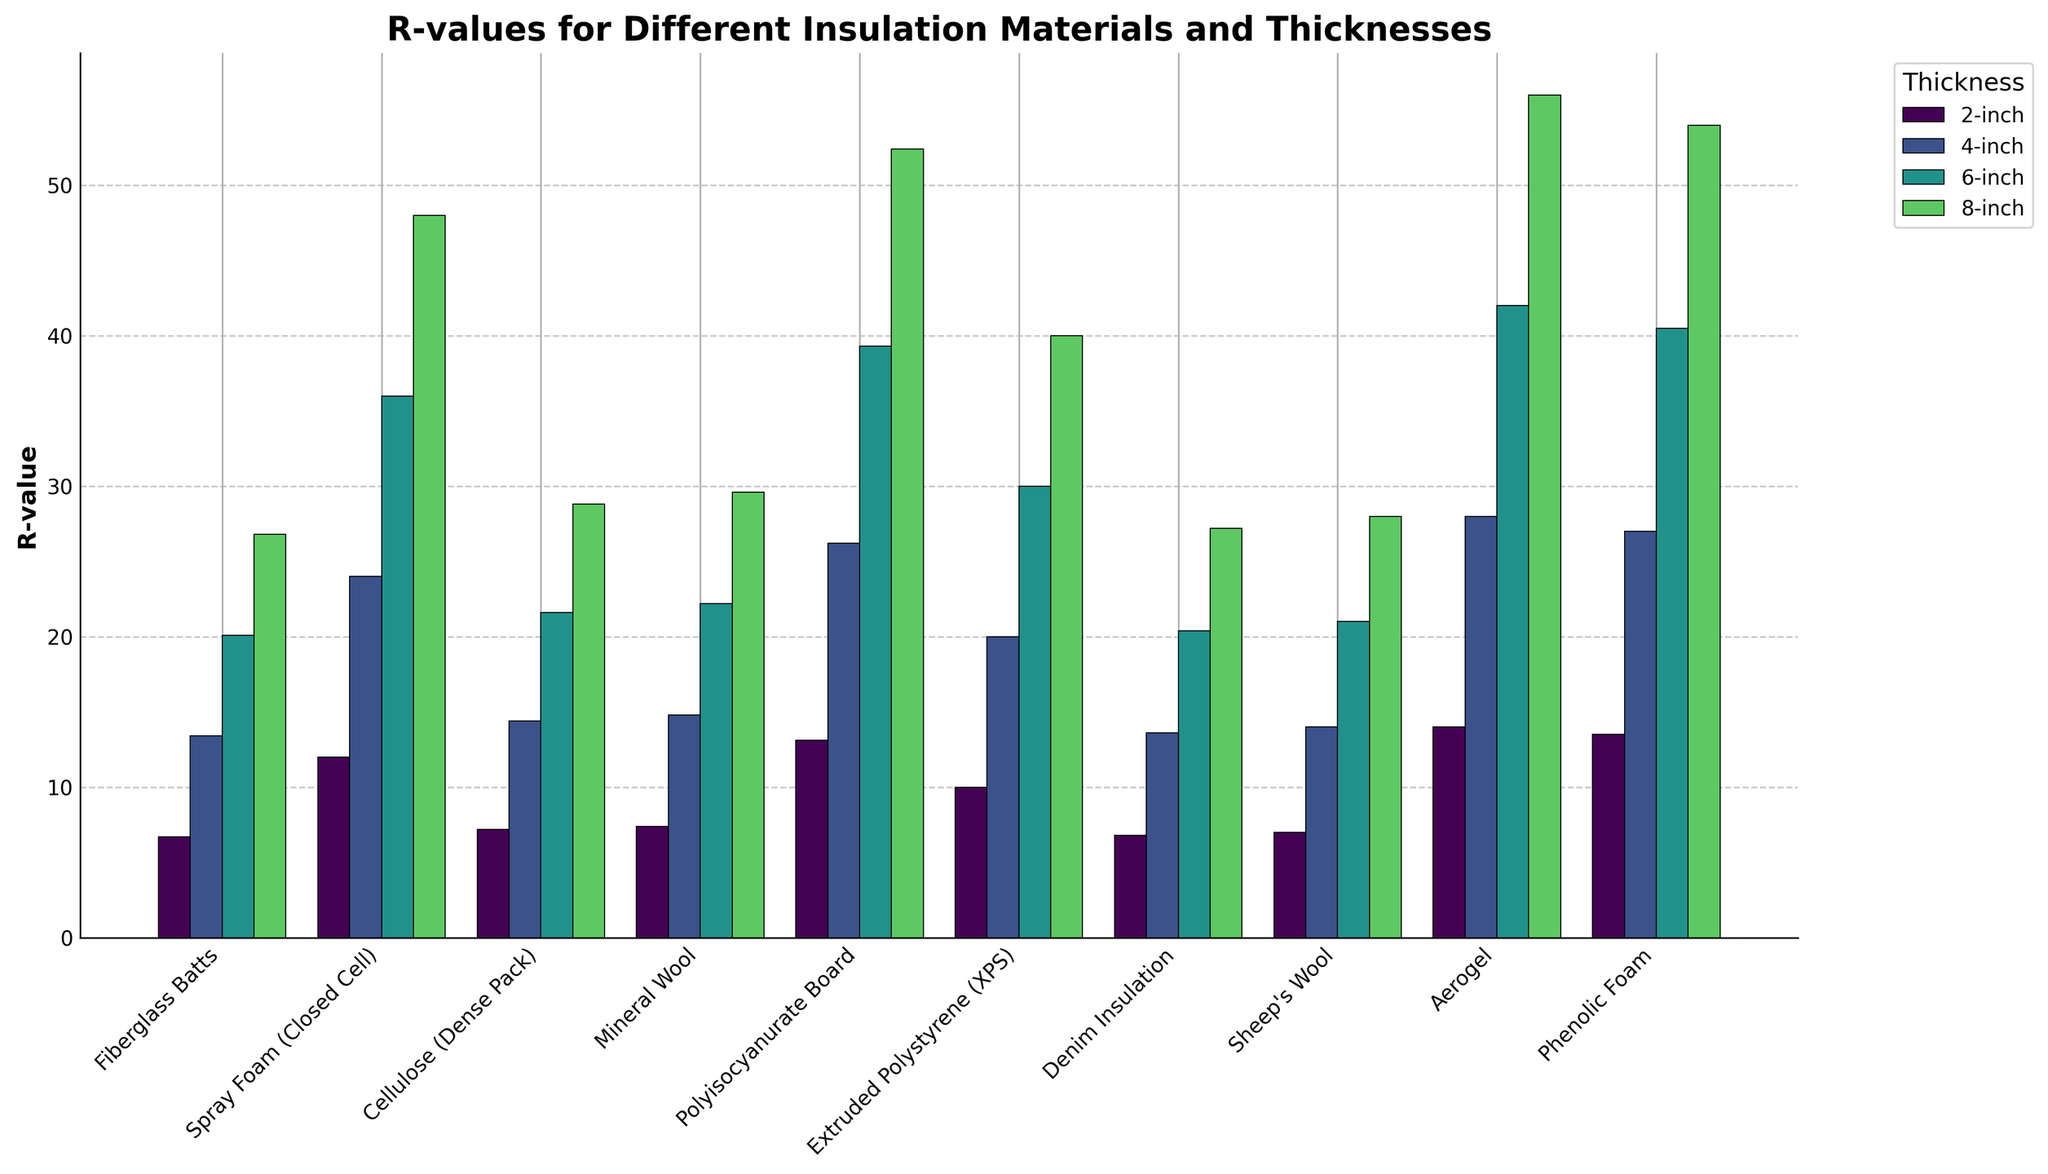Which insulation material has the highest 2-inch R-value? Locate the bars for 2-inch thickness on the figure. Identify the tallest bar that represents the highest R-value.
Answer: Aerogel How does the 4-inch R-value of Fiberglass Batts compare to that of Polyisocyanurate Board? Locate the bars for 4-inch thickness for both Fiberglass Batts and Polyisocyanurate Board. Compare their heights to determine which one is taller.
Answer: Polyisocyanurate Board is higher What's the average 6-inch R-value for Fiberglass Batts, Spray Foam (Closed Cell), and Cellulose (Dense Pack)? Identify the 6-inch R-values for Fiberglass Batts (20.1), Spray Foam (36.0), and Cellulose (21.6). Calculate the average: (20.1 + 36.0 + 21.6) / 3 = 25.9.
Answer: 25.9 Which material shows the least increase in R-value from 2-inch to 4-inch thickness? Calculate the increase for each material: subtract the 2-inch R-value from the 4-inch R-value. Identify the smallest difference.
Answer: Denim Insulation (6.8 to 13.6, increase of 6.8) What is the total R-value for 8-inch Spray Foam and 4-inch Aerogel combined? Locate the corresponding R-values for 8-inch Spray Foam (48.0) and 4-inch Aerogel (28.0). Add them together: 48.0 + 28.0 = 76.0.
Answer: 76.0 Is the R-value of 6-inch Sheep's Wool greater than the R-value of 4-inch Extruded Polystyrene (XPS)? Compare the R-values for 6-inch Sheep's Wool (21.0) and 4-inch XPS (20.0). Identify if the former is greater.
Answer: Yes Which material provides an R-value of at least 25.0 for 8-inch thickness but not more than 30.0? Identify the 8-inch R-values and find which ones fall between 25.0 and 30.0.
Answer: Fiberglass Batts, Cellulose (Dense Pack), Mineral Wool, Denim Insulation, Sheep's Wool Does Phenolic Foam at 4-inch thickness have a higher R-value than Mineral Wool at 6-inch thickness? Compare the R-values for Phenolic Foam at 4-inch (27.0) and Mineral Wool at 6-inch (22.2). Determine if the former is higher.
Answer: Yes Which material experiences the largest absolute R-value increase from 6 inches to 8 inches of thickness? Calculate the increase for each material from 6-inch to 8-inch by subtracting the 6-inch value from the 8-inch value. Identify the largest increase.
Answer: Aerogel (14) Rank the R-values of 8-inch Polyisocyanurate Board, Aerogel, and Phenolic Foam from highest to lowest. Find the 8-inch R-values: Polyisocyanurate Board (52.4), Aerogel (56.0), Phenolic Foam (54.0). Rank them: Aerogel > Phenolic Foam > Polyisocyanurate Board.
Answer: Aerogel, Phenolic Foam, Polyisocyanurate Board 